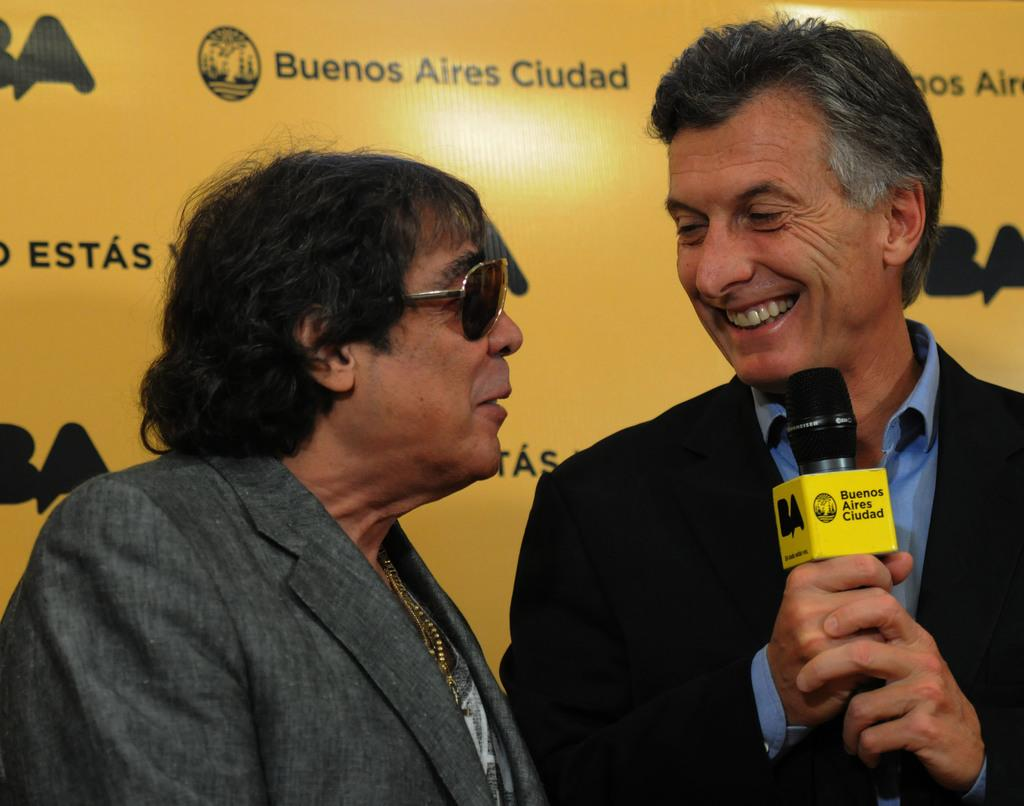How many people are in the image? There are two men in the image. What are the men doing in the image? The men are talking to each other. Can you describe what the second person is holding? The second person is holding a mic in his hand. What can be seen in the background of the image? There is a banner with some names on it in the background. What type of headwear is the bee wearing in the image? There is no bee present in the image, so it cannot be determined if a bee is wearing any headwear. Is there any grass visible in the image? The provided facts do not mention grass, so it cannot be determined if grass is visible in the image. 